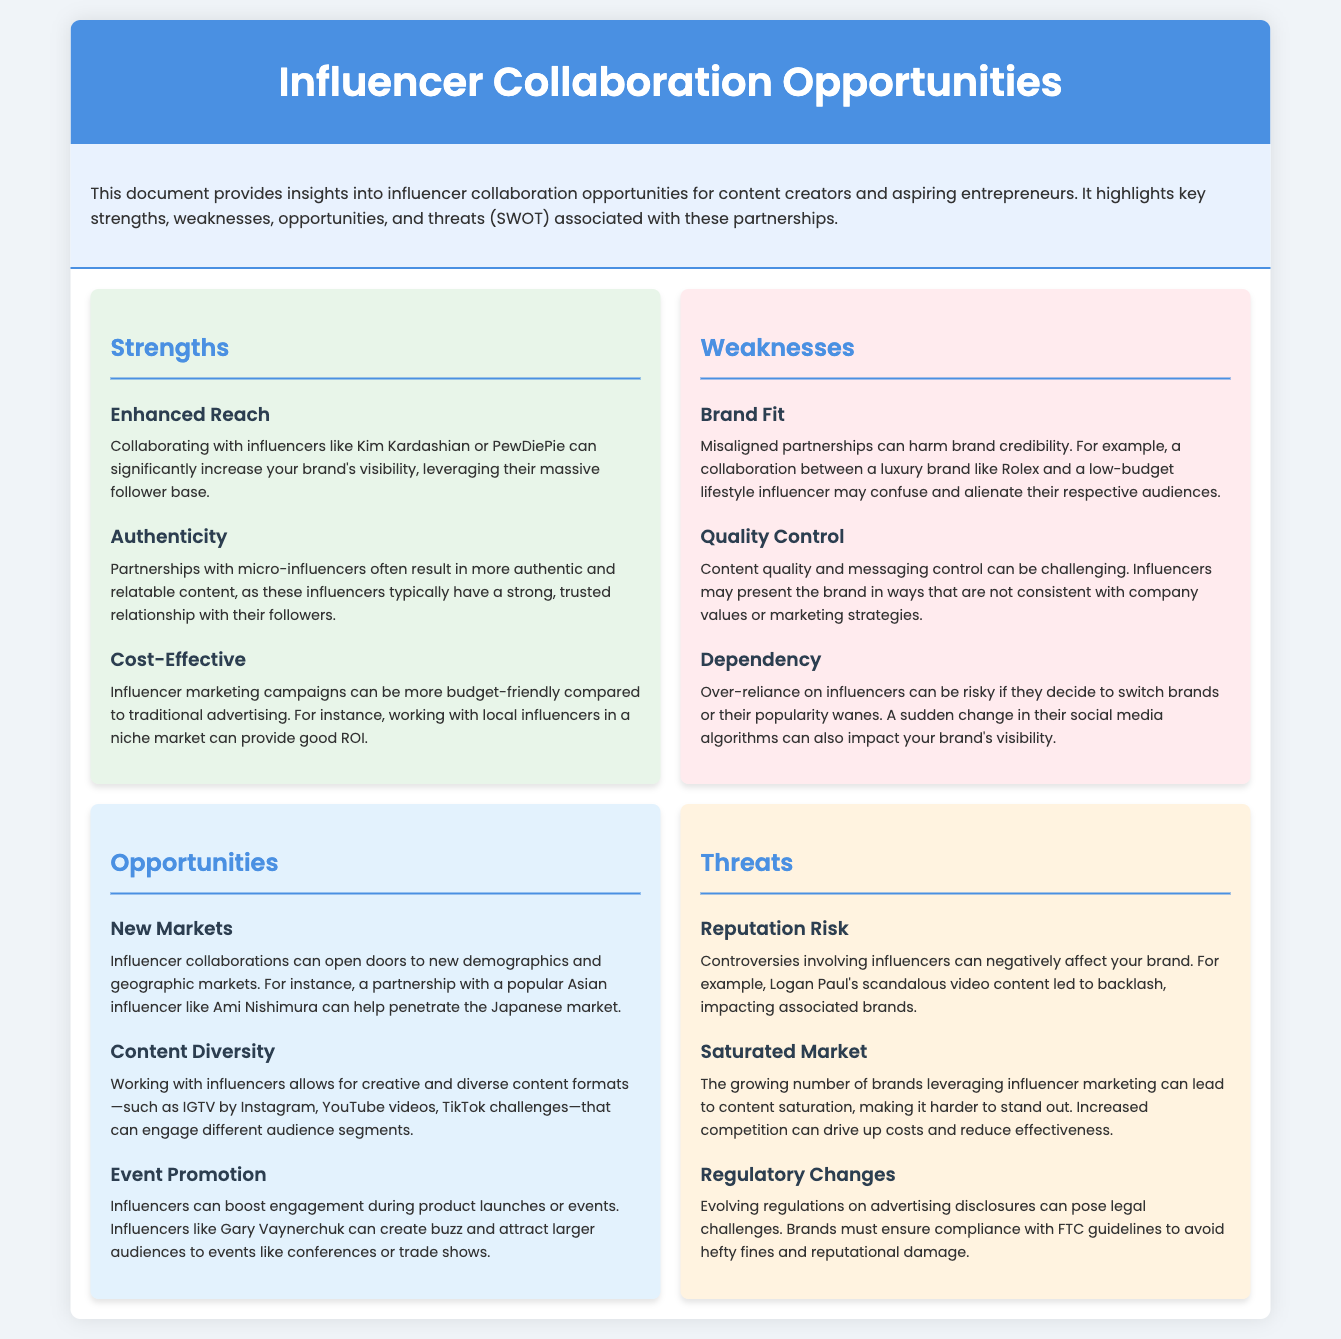What are the three strengths listed? The strengths highlighted in the document are Enhanced Reach, Authenticity, and Cost-Effective.
Answer: Enhanced Reach, Authenticity, Cost-Effective What is a weakness related to brand partnerships? One weakness mentioned is Brand Fit, where misaligned partnerships can harm brand credibility.
Answer: Brand Fit What is an opportunity mentioned for influencer collaborations? The document lists New Markets as an opportunity, where collaborations can open doors to new demographics.
Answer: New Markets Who can help penetrate the Japanese market according to the document? The text mentions Ami Nishimura as a popular influencer who can help penetrate the Japanese market.
Answer: Ami Nishimura What risk is associated with influencer controversies? Reputation Risk is noted as a threat where controversies involving influencers can negatively affect a brand.
Answer: Reputation Risk How can influencers enhance event promotion? They can boost engagement during product launches or events, as stated in the section on opportunities.
Answer: Boost engagement What can lead to content saturation in influencer marketing? The document points to a growing number of brands leveraging influencer marketing as a reason for content saturation.
Answer: Growing number of brands What regulatory challenge might brands face? Brands may face challenges related to evolving regulations on advertising disclosures.
Answer: Evolving regulations What is a challenge regarding quality control in influencer collaborations? Content quality and messaging control can be challenging as mentioned under weaknesses.
Answer: Quality control 